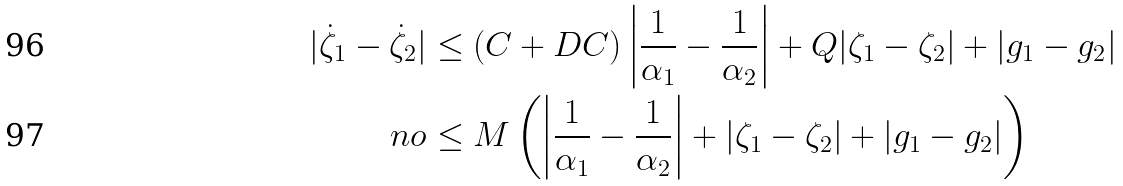Convert formula to latex. <formula><loc_0><loc_0><loc_500><loc_500>| \dot { \zeta } _ { 1 } - \dot { \zeta } _ { 2 } | & \leq ( C + D C ) \left | \frac { 1 } { \alpha _ { 1 } } - \frac { 1 } { \alpha _ { 2 } } \right | + Q | \zeta _ { 1 } - \zeta _ { 2 } | + | g _ { 1 } - g _ { 2 } | \\ \ n o & \leq M \left ( \left | \frac { 1 } { \alpha _ { 1 } } - \frac { 1 } { \alpha _ { 2 } } \right | + | \zeta _ { 1 } - \zeta _ { 2 } | + | g _ { 1 } - g _ { 2 } | \right )</formula> 